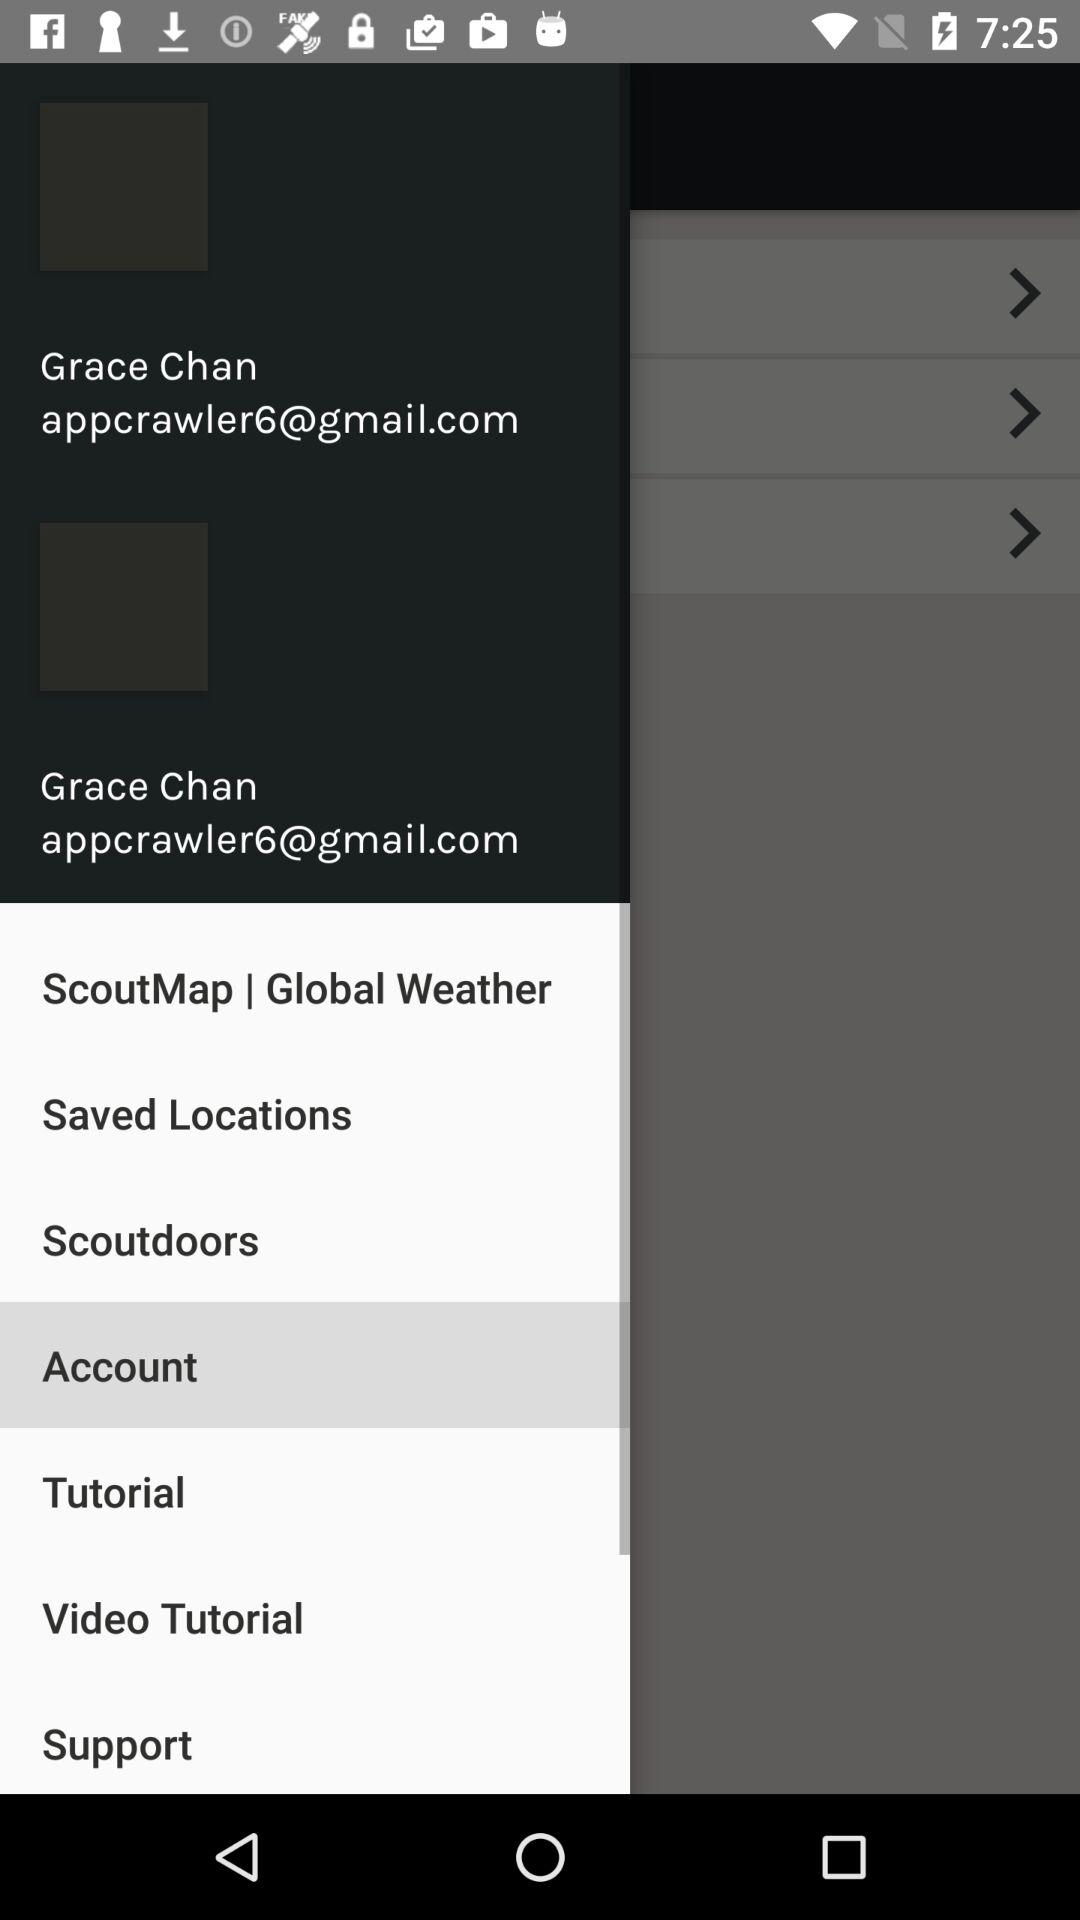Which is the selected item in the menu? The selected item in the menu is "Account". 